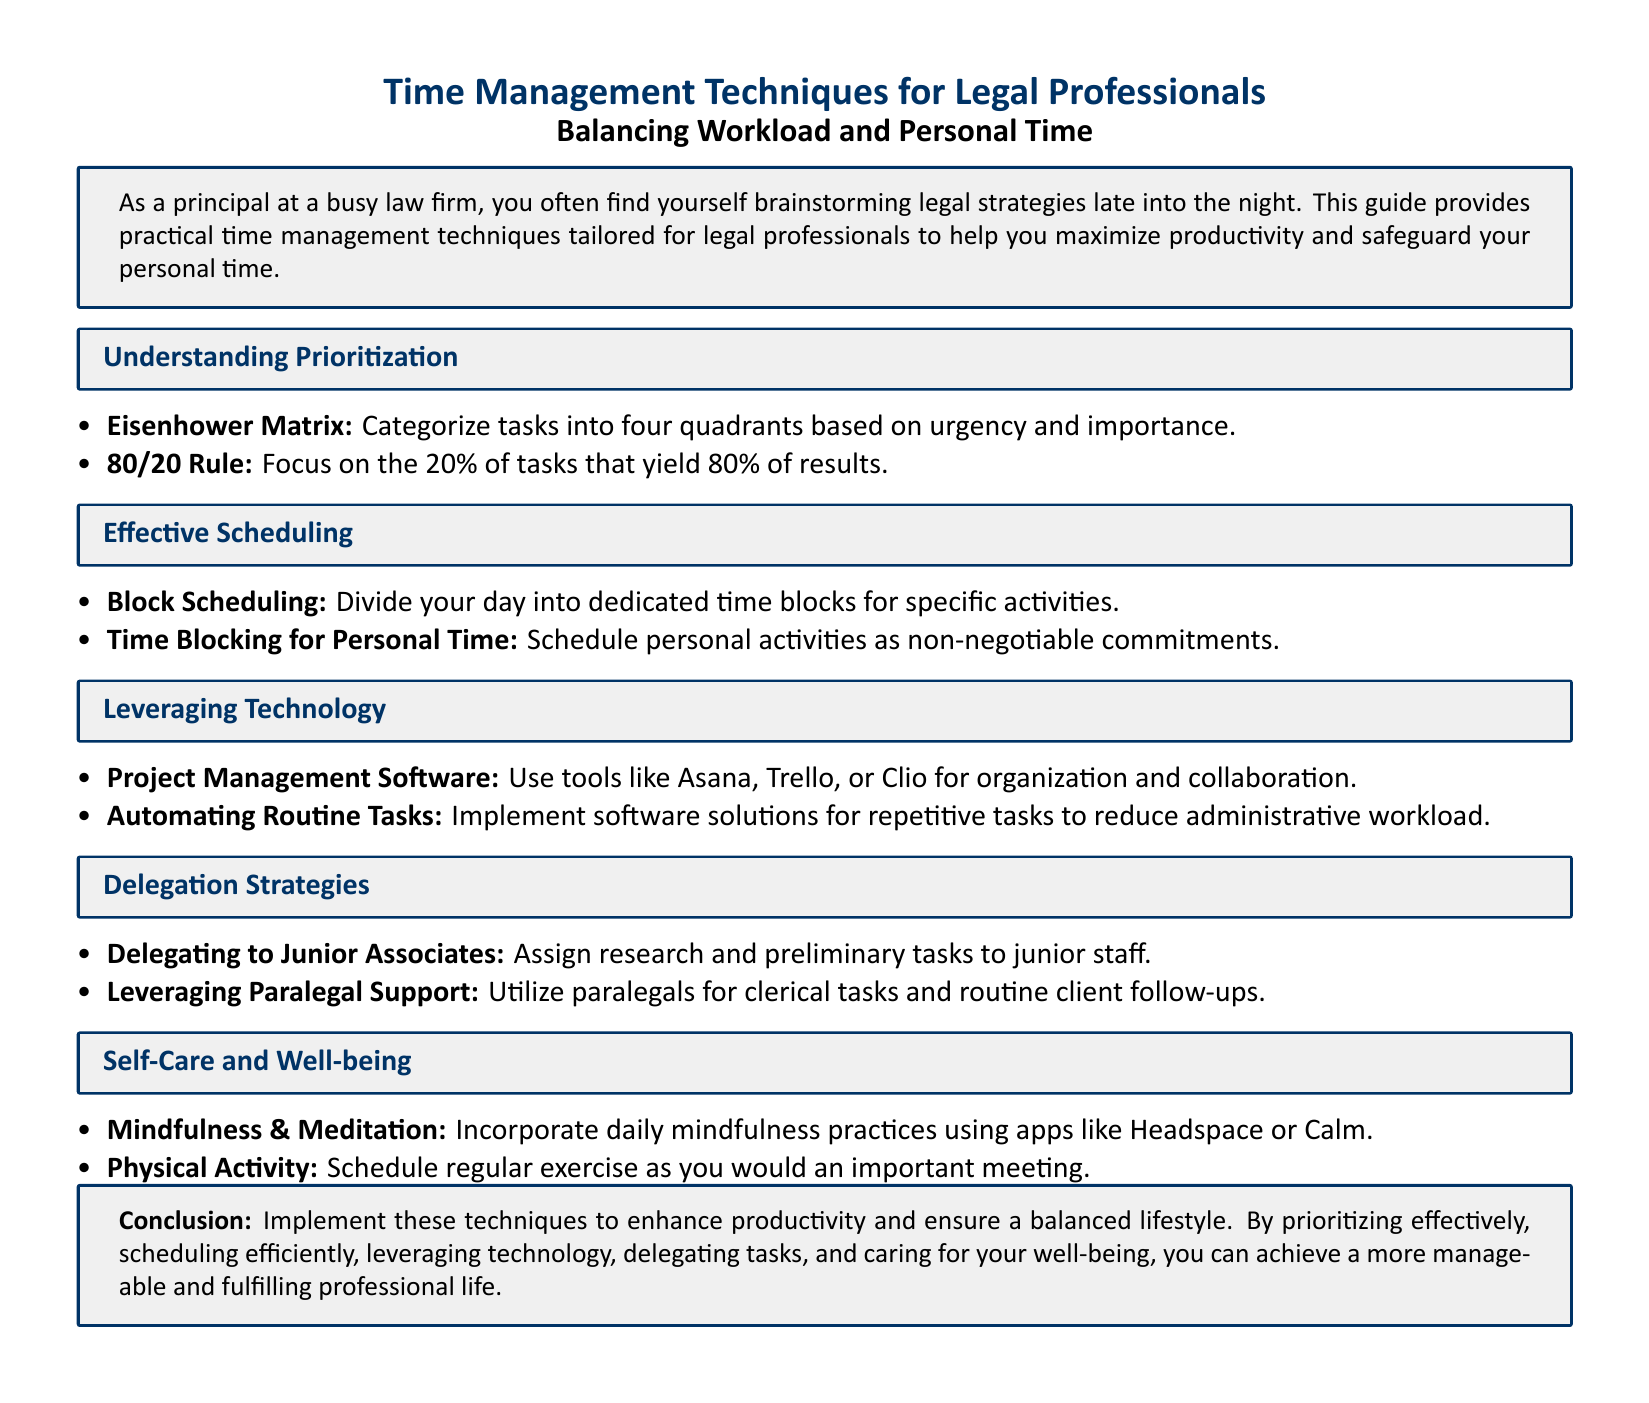what is the title of the document? The title is prominently mentioned at the top of the document.
Answer: Time Management Techniques for Legal Professionals what are the four quadrants of the Eisenhower Matrix? The document lists the Eisenhower Matrix under prioritization, but does not specify the quadrants.
Answer: Not specified what technique focuses on the 20% of tasks that yield 80% of results? This technique is mentioned under the section on prioritization.
Answer: 80/20 Rule what is an example of a project management software mentioned? Examples of software tools are provided in the technology section.
Answer: Asana what are two recommended mindfulness apps? The self-care section suggests specific apps for mindfulness.
Answer: Headspace or Calm how should physical activity be scheduled according to the document? The document emphasizes the importance of scheduling physical activity.
Answer: As an important meeting what is one recommended delegation strategy? A specific strategy for delegation is mentioned in the delegation strategy section.
Answer: Delegating to Junior Associates what is a non-negotiable commitment mentioned in scheduling? The document emphasizes the importance of committing to certain activities.
Answer: Personal activities what is the overall conclusion of the document? The conclusion summarizes the main objectives discussed throughout the document.
Answer: Enhance productivity and ensure a balanced lifestyle 